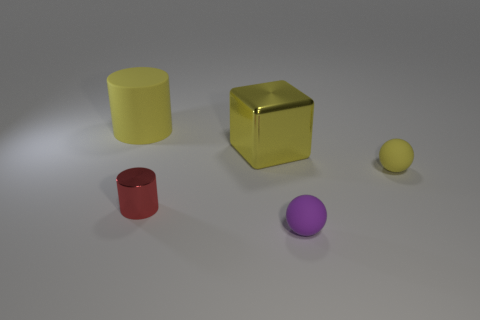There is a big cylinder that is the same color as the big block; what material is it?
Your answer should be compact. Rubber. What number of small rubber spheres are the same color as the large cylinder?
Keep it short and to the point. 1. What is the color of the block?
Offer a very short reply. Yellow. There is another sphere that is made of the same material as the yellow ball; what size is it?
Ensure brevity in your answer.  Small. What color is the object that is the same material as the red cylinder?
Provide a short and direct response. Yellow. Is there another purple rubber thing that has the same size as the purple object?
Your answer should be very brief. No. What material is the yellow object that is the same shape as the small red metallic thing?
Give a very brief answer. Rubber. There is a metal thing that is the same size as the yellow matte cylinder; what shape is it?
Provide a succinct answer. Cube. Is there a large rubber thing of the same shape as the small red object?
Ensure brevity in your answer.  Yes. What shape is the shiny thing that is behind the yellow matte object on the right side of the metal cylinder?
Keep it short and to the point. Cube. 